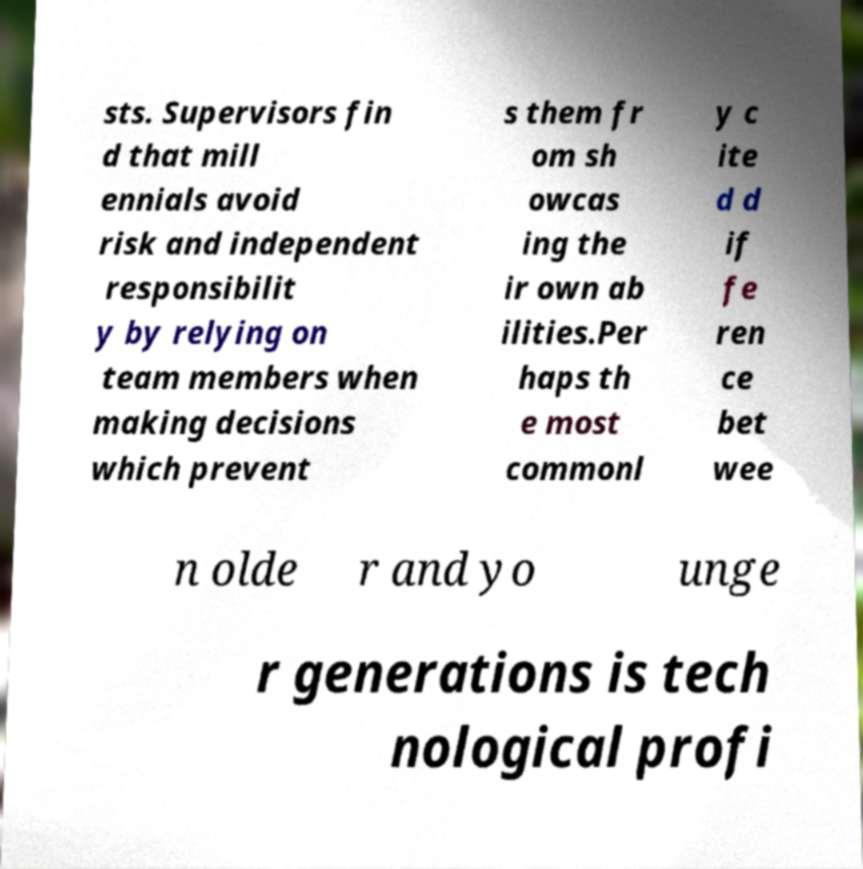There's text embedded in this image that I need extracted. Can you transcribe it verbatim? sts. Supervisors fin d that mill ennials avoid risk and independent responsibilit y by relying on team members when making decisions which prevent s them fr om sh owcas ing the ir own ab ilities.Per haps th e most commonl y c ite d d if fe ren ce bet wee n olde r and yo unge r generations is tech nological profi 